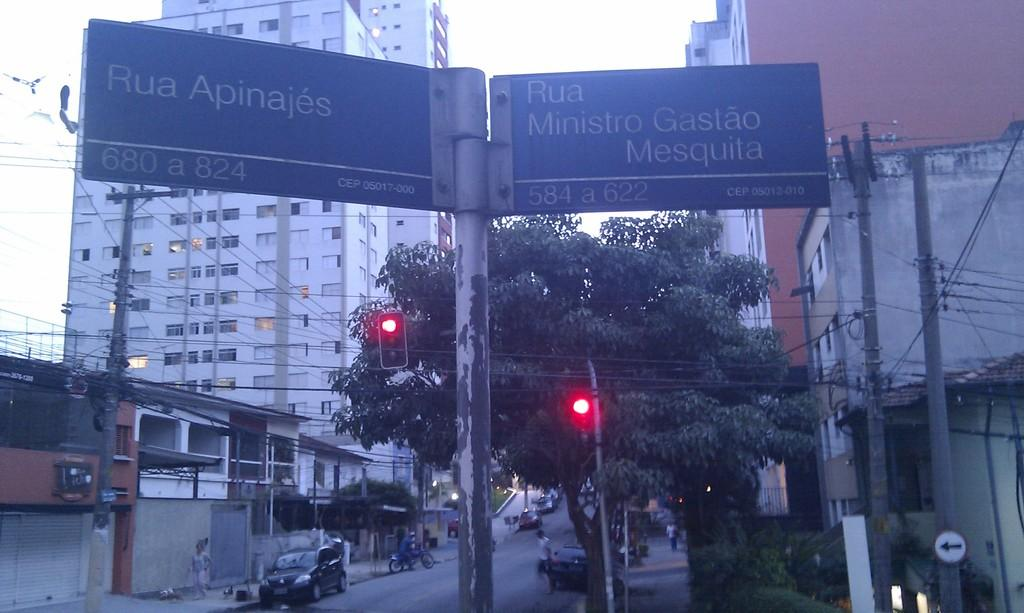Provide a one-sentence caption for the provided image. a sign above the ground that says Ria on it. 